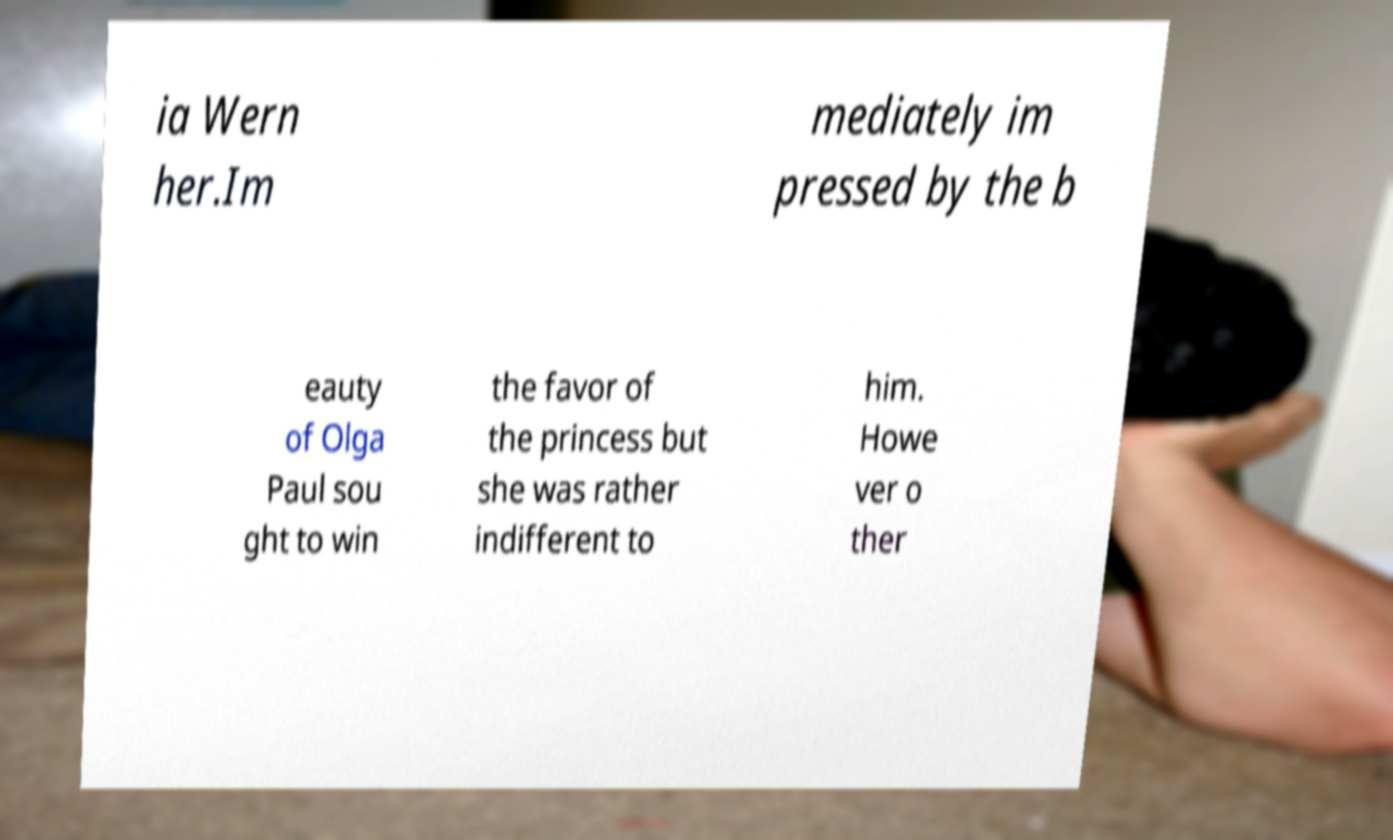For documentation purposes, I need the text within this image transcribed. Could you provide that? ia Wern her.Im mediately im pressed by the b eauty of Olga Paul sou ght to win the favor of the princess but she was rather indifferent to him. Howe ver o ther 